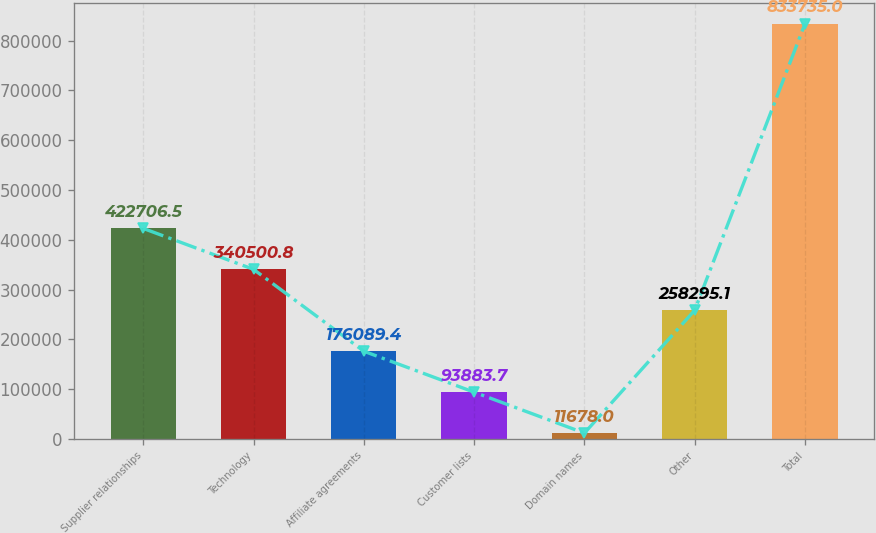<chart> <loc_0><loc_0><loc_500><loc_500><bar_chart><fcel>Supplier relationships<fcel>Technology<fcel>Affiliate agreements<fcel>Customer lists<fcel>Domain names<fcel>Other<fcel>Total<nl><fcel>422706<fcel>340501<fcel>176089<fcel>93883.7<fcel>11678<fcel>258295<fcel>833735<nl></chart> 